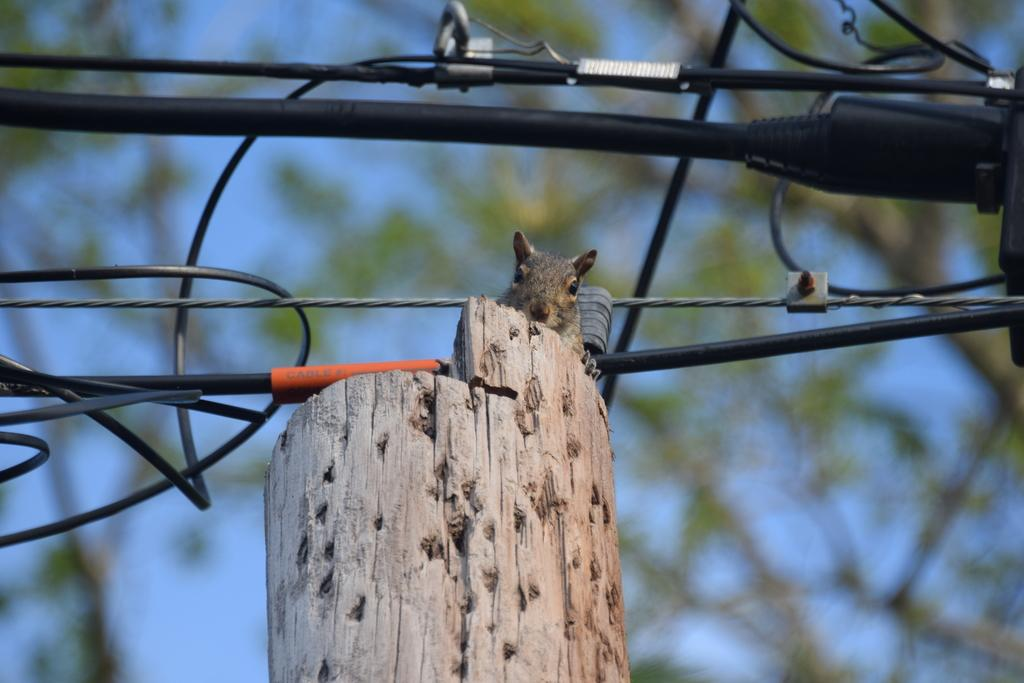What animal can be seen in the image? There is a squirrel in the image. What is the squirrel standing on? The squirrel is on a wooden object. What else can be seen in the image besides the squirrel? There are cables visible in the image. What is visible in the background of the image? The background of the image is blurry, but the sky is visible. What type of plant is the squirrel using as bait in the image? There is no plant or bait present in the image; it features a squirrel standing on a wooden object with cables visible in the background. What kind of car can be seen in the image? There is no car present in the image. 